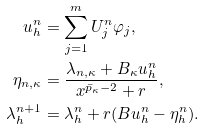<formula> <loc_0><loc_0><loc_500><loc_500>u ^ { n } _ { h } & = \sum _ { j = 1 } ^ { m } U ^ { n } _ { j } \varphi _ { j } , \\ \eta _ { n , { \kappa } } & = \frac { \lambda _ { n , { \kappa } } + B _ { \kappa } u ^ { n } _ { h } } { x ^ { \bar { p } _ { \kappa } - 2 } + r } , \\ \lambda ^ { n + 1 } _ { h } & = \lambda ^ { n } _ { h } + r ( B u ^ { n } _ { h } - \eta ^ { n } _ { h } ) .</formula> 